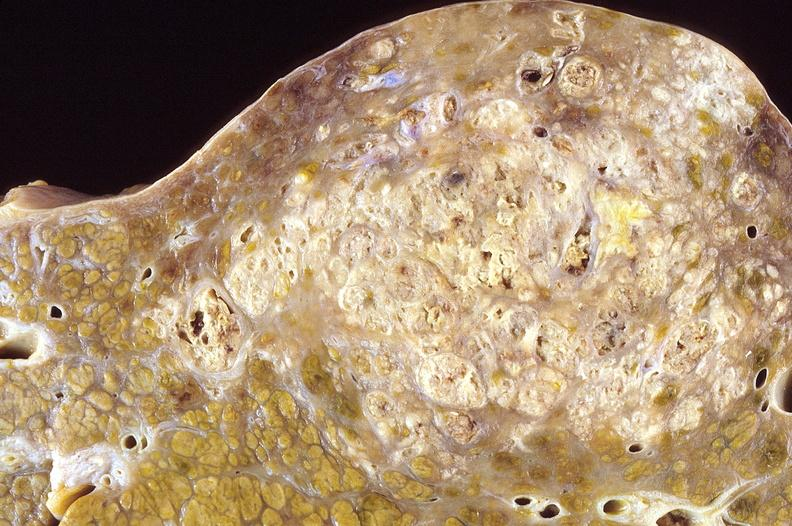what is present?
Answer the question using a single word or phrase. Hepatobiliary 